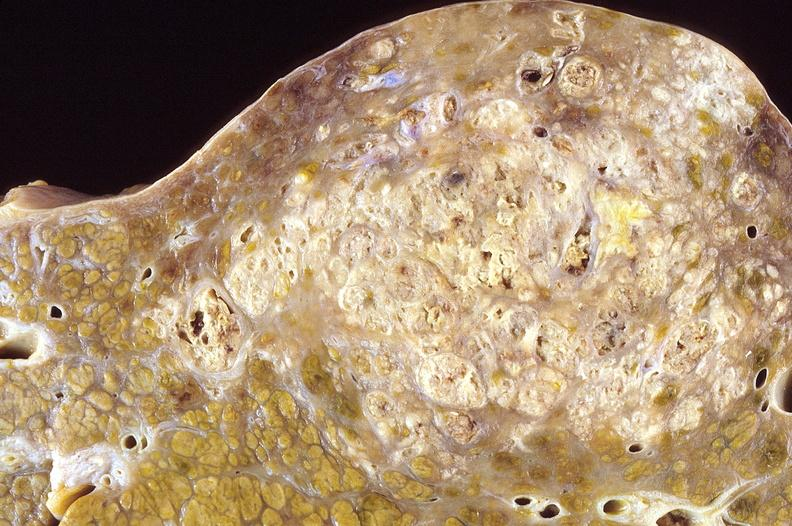what is present?
Answer the question using a single word or phrase. Hepatobiliary 